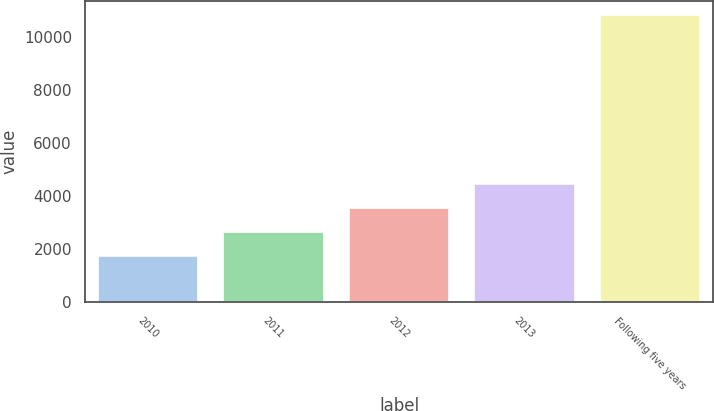<chart> <loc_0><loc_0><loc_500><loc_500><bar_chart><fcel>2010<fcel>2011<fcel>2012<fcel>2013<fcel>Following five years<nl><fcel>1750<fcel>2655.4<fcel>3560.8<fcel>4466.2<fcel>10804<nl></chart> 